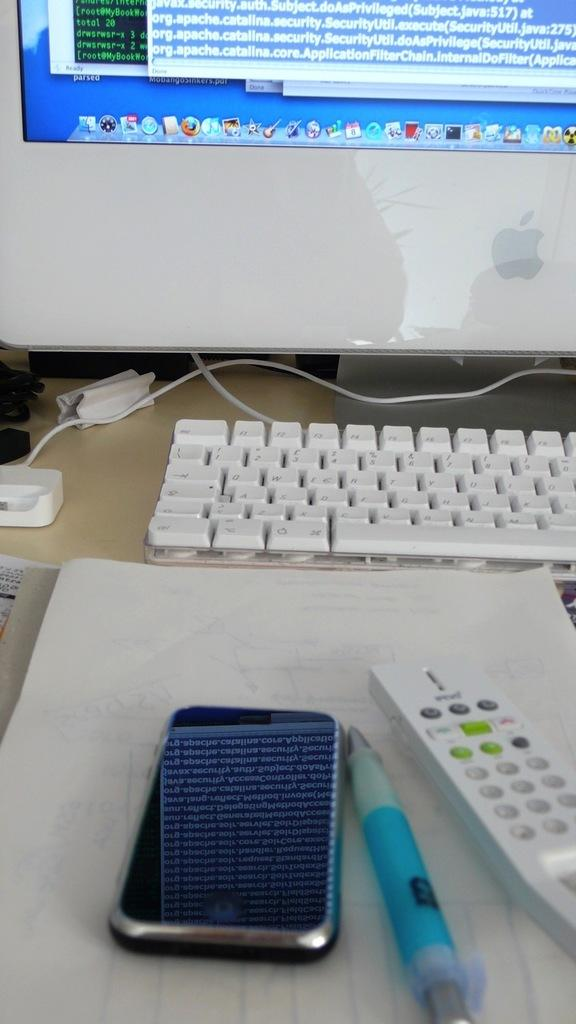<image>
Provide a brief description of the given image. A CELL PHONE, PEN ANF REMOTE ON TABLE IN FRONT OF A MAC COMPUTER AND KEYBOARD 